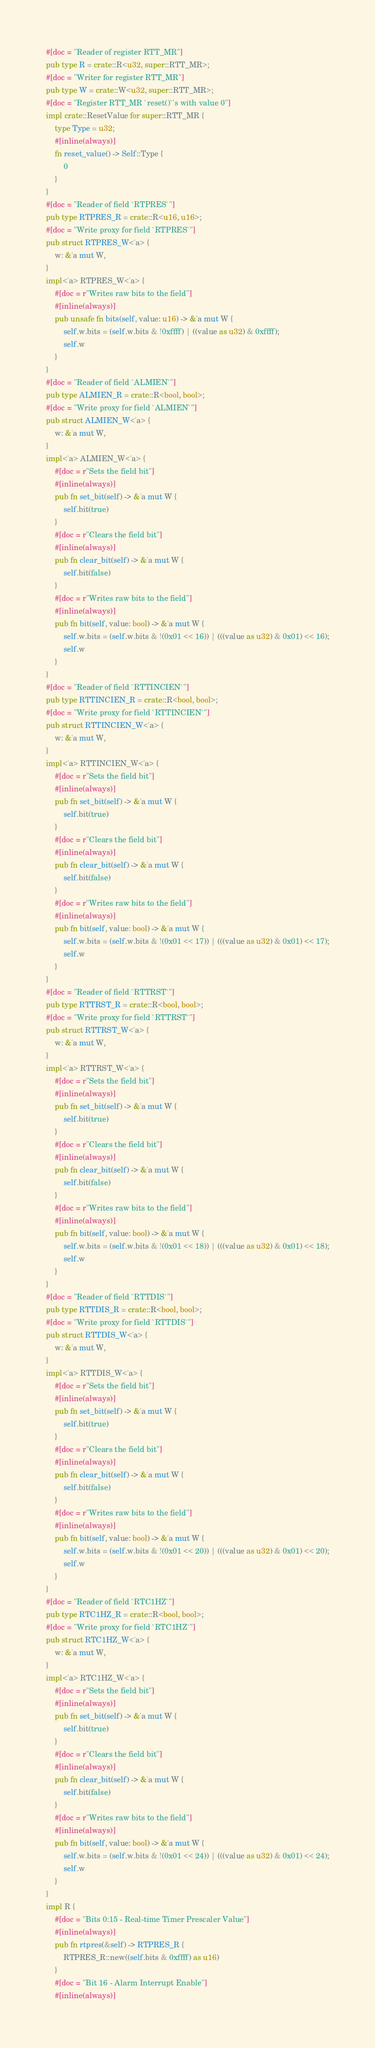Convert code to text. <code><loc_0><loc_0><loc_500><loc_500><_Rust_>#[doc = "Reader of register RTT_MR"]
pub type R = crate::R<u32, super::RTT_MR>;
#[doc = "Writer for register RTT_MR"]
pub type W = crate::W<u32, super::RTT_MR>;
#[doc = "Register RTT_MR `reset()`'s with value 0"]
impl crate::ResetValue for super::RTT_MR {
    type Type = u32;
    #[inline(always)]
    fn reset_value() -> Self::Type {
        0
    }
}
#[doc = "Reader of field `RTPRES`"]
pub type RTPRES_R = crate::R<u16, u16>;
#[doc = "Write proxy for field `RTPRES`"]
pub struct RTPRES_W<'a> {
    w: &'a mut W,
}
impl<'a> RTPRES_W<'a> {
    #[doc = r"Writes raw bits to the field"]
    #[inline(always)]
    pub unsafe fn bits(self, value: u16) -> &'a mut W {
        self.w.bits = (self.w.bits & !0xffff) | ((value as u32) & 0xffff);
        self.w
    }
}
#[doc = "Reader of field `ALMIEN`"]
pub type ALMIEN_R = crate::R<bool, bool>;
#[doc = "Write proxy for field `ALMIEN`"]
pub struct ALMIEN_W<'a> {
    w: &'a mut W,
}
impl<'a> ALMIEN_W<'a> {
    #[doc = r"Sets the field bit"]
    #[inline(always)]
    pub fn set_bit(self) -> &'a mut W {
        self.bit(true)
    }
    #[doc = r"Clears the field bit"]
    #[inline(always)]
    pub fn clear_bit(self) -> &'a mut W {
        self.bit(false)
    }
    #[doc = r"Writes raw bits to the field"]
    #[inline(always)]
    pub fn bit(self, value: bool) -> &'a mut W {
        self.w.bits = (self.w.bits & !(0x01 << 16)) | (((value as u32) & 0x01) << 16);
        self.w
    }
}
#[doc = "Reader of field `RTTINCIEN`"]
pub type RTTINCIEN_R = crate::R<bool, bool>;
#[doc = "Write proxy for field `RTTINCIEN`"]
pub struct RTTINCIEN_W<'a> {
    w: &'a mut W,
}
impl<'a> RTTINCIEN_W<'a> {
    #[doc = r"Sets the field bit"]
    #[inline(always)]
    pub fn set_bit(self) -> &'a mut W {
        self.bit(true)
    }
    #[doc = r"Clears the field bit"]
    #[inline(always)]
    pub fn clear_bit(self) -> &'a mut W {
        self.bit(false)
    }
    #[doc = r"Writes raw bits to the field"]
    #[inline(always)]
    pub fn bit(self, value: bool) -> &'a mut W {
        self.w.bits = (self.w.bits & !(0x01 << 17)) | (((value as u32) & 0x01) << 17);
        self.w
    }
}
#[doc = "Reader of field `RTTRST`"]
pub type RTTRST_R = crate::R<bool, bool>;
#[doc = "Write proxy for field `RTTRST`"]
pub struct RTTRST_W<'a> {
    w: &'a mut W,
}
impl<'a> RTTRST_W<'a> {
    #[doc = r"Sets the field bit"]
    #[inline(always)]
    pub fn set_bit(self) -> &'a mut W {
        self.bit(true)
    }
    #[doc = r"Clears the field bit"]
    #[inline(always)]
    pub fn clear_bit(self) -> &'a mut W {
        self.bit(false)
    }
    #[doc = r"Writes raw bits to the field"]
    #[inline(always)]
    pub fn bit(self, value: bool) -> &'a mut W {
        self.w.bits = (self.w.bits & !(0x01 << 18)) | (((value as u32) & 0x01) << 18);
        self.w
    }
}
#[doc = "Reader of field `RTTDIS`"]
pub type RTTDIS_R = crate::R<bool, bool>;
#[doc = "Write proxy for field `RTTDIS`"]
pub struct RTTDIS_W<'a> {
    w: &'a mut W,
}
impl<'a> RTTDIS_W<'a> {
    #[doc = r"Sets the field bit"]
    #[inline(always)]
    pub fn set_bit(self) -> &'a mut W {
        self.bit(true)
    }
    #[doc = r"Clears the field bit"]
    #[inline(always)]
    pub fn clear_bit(self) -> &'a mut W {
        self.bit(false)
    }
    #[doc = r"Writes raw bits to the field"]
    #[inline(always)]
    pub fn bit(self, value: bool) -> &'a mut W {
        self.w.bits = (self.w.bits & !(0x01 << 20)) | (((value as u32) & 0x01) << 20);
        self.w
    }
}
#[doc = "Reader of field `RTC1HZ`"]
pub type RTC1HZ_R = crate::R<bool, bool>;
#[doc = "Write proxy for field `RTC1HZ`"]
pub struct RTC1HZ_W<'a> {
    w: &'a mut W,
}
impl<'a> RTC1HZ_W<'a> {
    #[doc = r"Sets the field bit"]
    #[inline(always)]
    pub fn set_bit(self) -> &'a mut W {
        self.bit(true)
    }
    #[doc = r"Clears the field bit"]
    #[inline(always)]
    pub fn clear_bit(self) -> &'a mut W {
        self.bit(false)
    }
    #[doc = r"Writes raw bits to the field"]
    #[inline(always)]
    pub fn bit(self, value: bool) -> &'a mut W {
        self.w.bits = (self.w.bits & !(0x01 << 24)) | (((value as u32) & 0x01) << 24);
        self.w
    }
}
impl R {
    #[doc = "Bits 0:15 - Real-time Timer Prescaler Value"]
    #[inline(always)]
    pub fn rtpres(&self) -> RTPRES_R {
        RTPRES_R::new((self.bits & 0xffff) as u16)
    }
    #[doc = "Bit 16 - Alarm Interrupt Enable"]
    #[inline(always)]</code> 